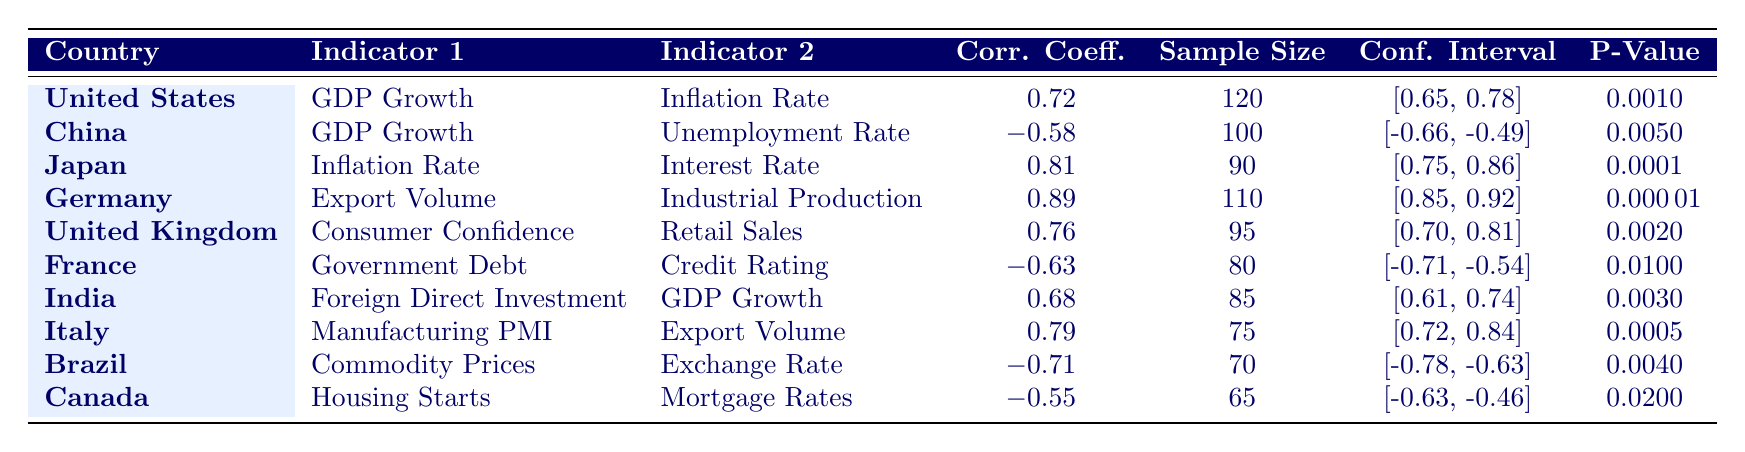What is the highest correlation coefficient recorded in the table? By inspecting the Correlation Coefficient column, we identify that the highest value is 0.89, which corresponds to Germany's Export Volume and Industrial Production.
Answer: 0.89 Which country has a negative correlation between its economic indicators? Looking for negative values in the Correlation Coefficient column, we find that China (-0.58), France (-0.63), Brazil (-0.71), and Canada (-0.55) have negative correlations.
Answer: China, France, Brazil, Canada What is the average correlation coefficient for all countries listed? To find the average, we sum all the correlation coefficients: 0.72 + (-0.58) + 0.81 + 0.89 + 0.76 + (-0.63) + 0.68 + 0.79 + (-0.71) + (-0.55) = 2.66. There are 10 countries, so the average is 2.66 / 10 = 0.266.
Answer: 0.266 Is the P-Value for Japan's indicators less than 0.001? The P-Value for Japan is 0.0001, which is less than 0.001, indicating a significant correlation between Inflation Rate and Interest Rate.
Answer: Yes Which countries have a P-Value below 0.005? Checking the P-Value column, we see that Japan (0.0001), Germany (0.00001), and China (0.005) have P-Values below 0.005.
Answer: Japan, Germany, China What is the difference in correlation coefficients between Germany and Brazil's indicators? Germany has a correlation coefficient of 0.89, and Brazil has -0.71. The difference is 0.89 - (-0.71) = 0.89 + 0.71 = 1.60.
Answer: 1.60 How many countries have a sample size greater than 100? By reviewing the Sample Size column, the countries with a sample size greater than 100 are the United States (120) and Germany (110), which totals 2 countries.
Answer: 2 Is the correlation coefficient for India's Foreign Direct Investment and GDP Growth positive? The correlation coefficient for India is 0.68, which is positive, indicating a positive relationship between Foreign Direct Investment and GDP Growth.
Answer: Yes Which indicators have consistently high positive correlation coefficients across all countries? Analyzing the table, we find no indicator with consistently high positive correlation across all countries, as the correlations vary greatly between different country pairs.
Answer: No 